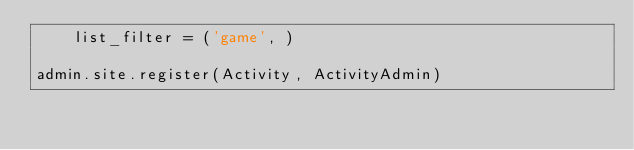Convert code to text. <code><loc_0><loc_0><loc_500><loc_500><_Python_>    list_filter = ('game', )

admin.site.register(Activity, ActivityAdmin)
</code> 